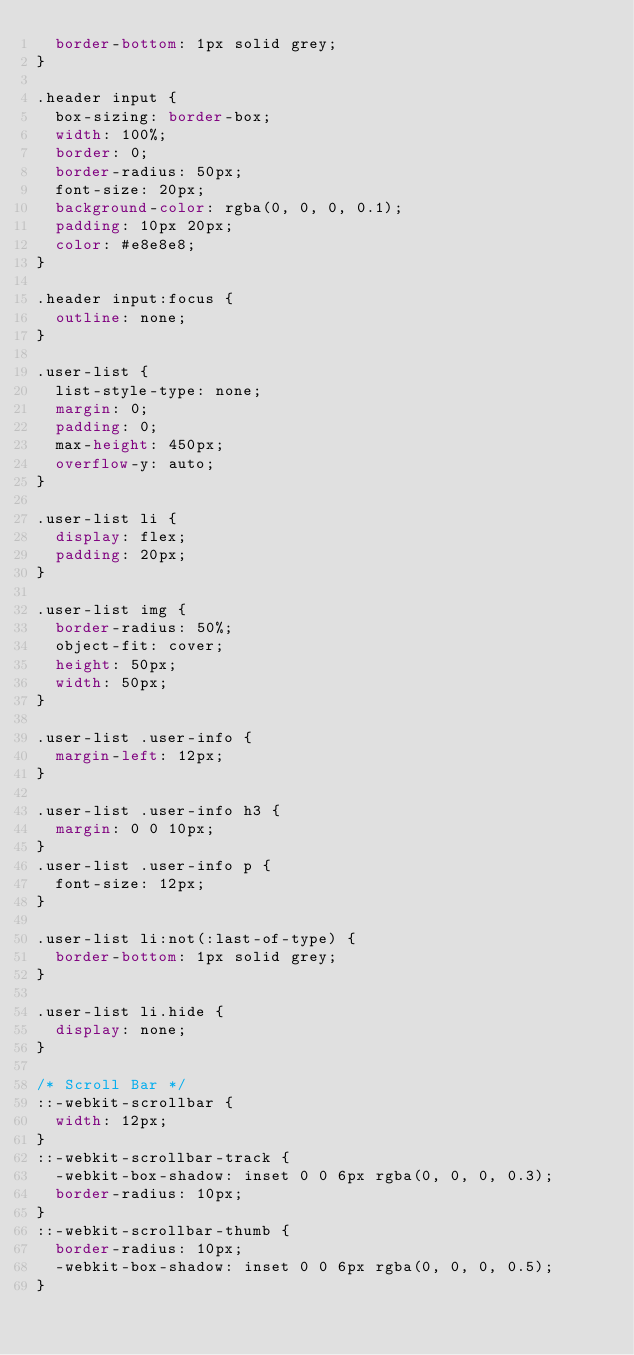<code> <loc_0><loc_0><loc_500><loc_500><_CSS_>  border-bottom: 1px solid grey;
}

.header input {
  box-sizing: border-box;
  width: 100%;
  border: 0;
  border-radius: 50px;
  font-size: 20px;
  background-color: rgba(0, 0, 0, 0.1);
  padding: 10px 20px;
  color: #e8e8e8;
}

.header input:focus {
  outline: none;
}

.user-list {
  list-style-type: none;
  margin: 0;
  padding: 0;
  max-height: 450px;
  overflow-y: auto;
}

.user-list li {
  display: flex;
  padding: 20px;
}

.user-list img {
  border-radius: 50%;
  object-fit: cover;
  height: 50px;
  width: 50px;
}

.user-list .user-info {
  margin-left: 12px;
}

.user-list .user-info h3 {
  margin: 0 0 10px;
}
.user-list .user-info p {
  font-size: 12px;
}

.user-list li:not(:last-of-type) {
  border-bottom: 1px solid grey;
}

.user-list li.hide {
  display: none;
}

/* Scroll Bar */
::-webkit-scrollbar {
  width: 12px;
}
::-webkit-scrollbar-track {
  -webkit-box-shadow: inset 0 0 6px rgba(0, 0, 0, 0.3);
  border-radius: 10px;
}
::-webkit-scrollbar-thumb {
  border-radius: 10px;
  -webkit-box-shadow: inset 0 0 6px rgba(0, 0, 0, 0.5);
}
</code> 